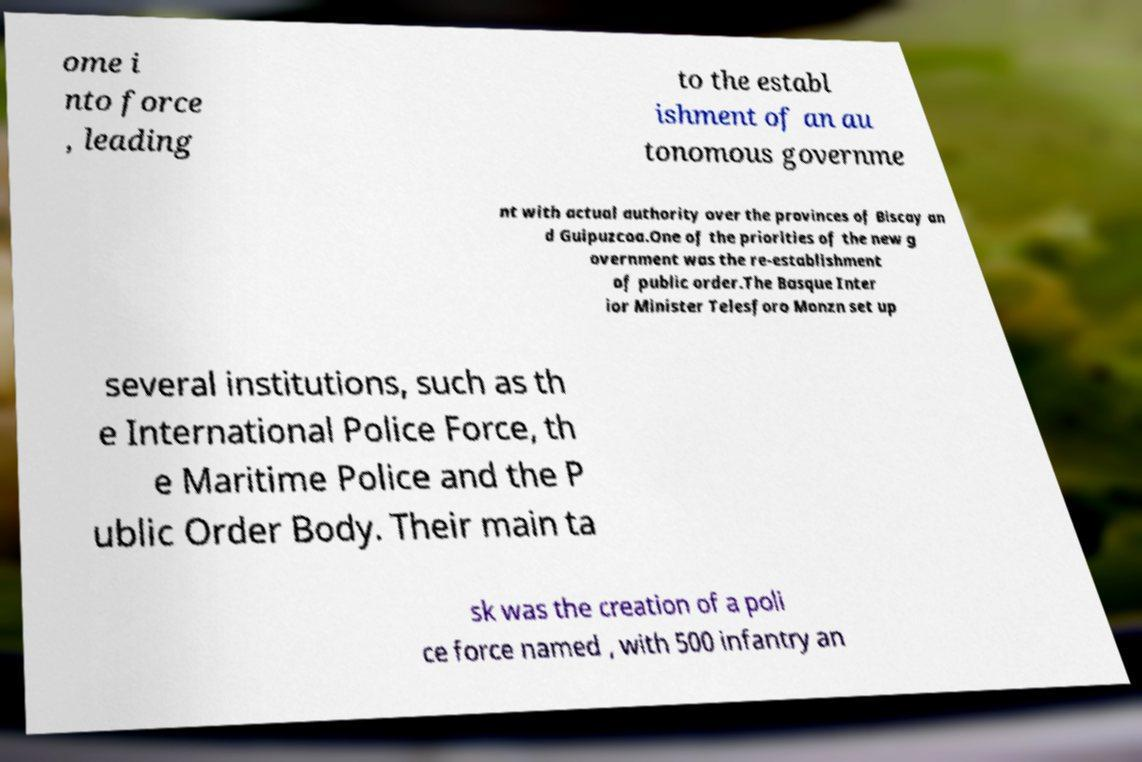What messages or text are displayed in this image? I need them in a readable, typed format. ome i nto force , leading to the establ ishment of an au tonomous governme nt with actual authority over the provinces of Biscay an d Guipuzcoa.One of the priorities of the new g overnment was the re-establishment of public order.The Basque Inter ior Minister Telesforo Monzn set up several institutions, such as th e International Police Force, th e Maritime Police and the P ublic Order Body. Their main ta sk was the creation of a poli ce force named , with 500 infantry an 